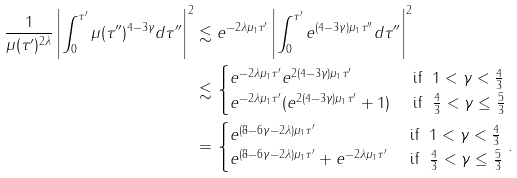<formula> <loc_0><loc_0><loc_500><loc_500>\frac { 1 } { \mu ( \tau ^ { \prime } ) ^ { 2 \lambda } } \left | \int _ { 0 } ^ { \tau ^ { \prime } } \mu ( \tau ^ { \prime \prime } ) ^ { 4 - 3 \gamma } d \tau ^ { \prime \prime } \right | ^ { 2 } & \lesssim e ^ { - 2 \lambda \mu _ { 1 } \tau ^ { \prime } } \left | \int _ { 0 } ^ { \tau ^ { \prime } } e ^ { ( 4 - 3 \gamma ) \mu _ { 1 } \tau ^ { \prime \prime } } d \tau ^ { \prime \prime } \right | ^ { 2 } \\ & \lesssim \begin{cases} e ^ { - 2 \lambda \mu _ { 1 } \tau ^ { \prime } } e ^ { 2 ( 4 - 3 \gamma ) \mu _ { 1 } \tau ^ { \prime } } & \text { if } \ 1 < \gamma < \frac { 4 } { 3 } \\ e ^ { - 2 \lambda \mu _ { 1 } \tau ^ { \prime } } ( e ^ { 2 ( 4 - 3 \gamma ) \mu _ { 1 } \tau ^ { \prime } } + 1 ) & \text { if } \ \frac { 4 } { 3 } < \gamma \leq \frac { 5 } { 3 } \end{cases} \\ & = \begin{cases} e ^ { ( 8 - 6 \gamma - 2 \lambda ) \mu _ { 1 } \tau ^ { \prime } } & \text { if } \ 1 < \gamma < \frac { 4 } { 3 } \\ e ^ { ( 8 - 6 \gamma - 2 \lambda ) \mu _ { 1 } \tau ^ { \prime } } + e ^ { - 2 \lambda \mu _ { 1 } \tau ^ { \prime } } & \text { if } \ \frac { 4 } { 3 } < \gamma \leq \frac { 5 } { 3 } \end{cases} .</formula> 